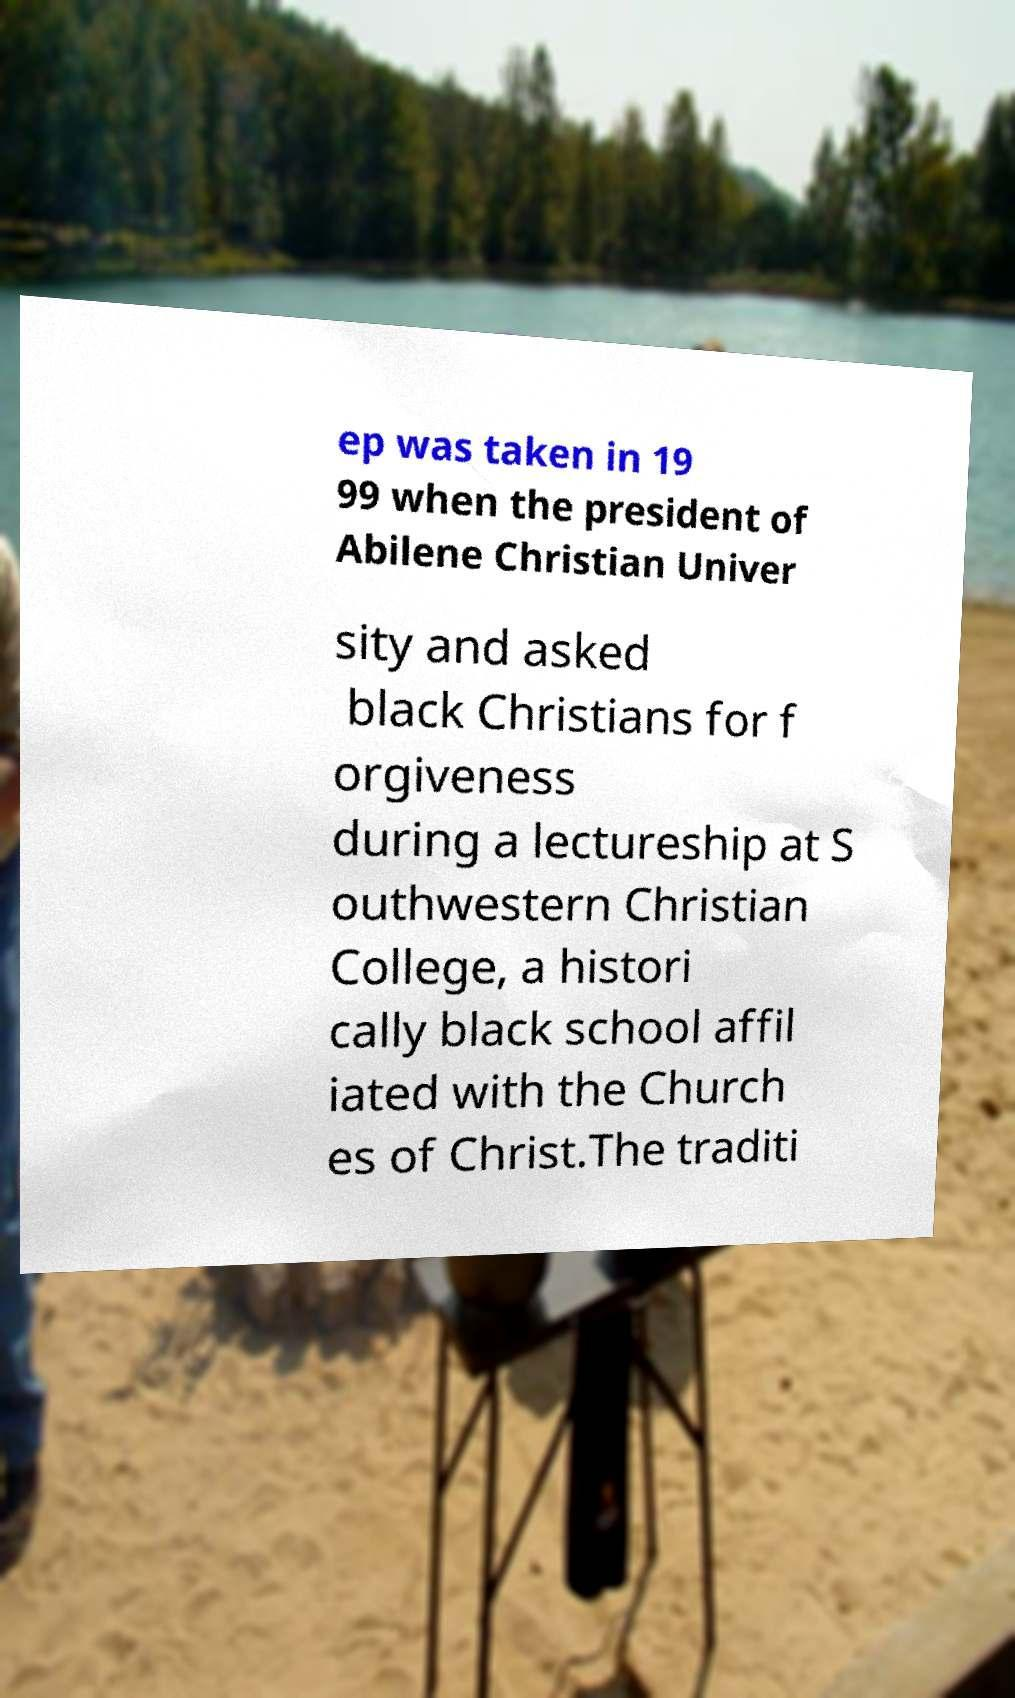Please read and relay the text visible in this image. What does it say? ep was taken in 19 99 when the president of Abilene Christian Univer sity and asked black Christians for f orgiveness during a lectureship at S outhwestern Christian College, a histori cally black school affil iated with the Church es of Christ.The traditi 